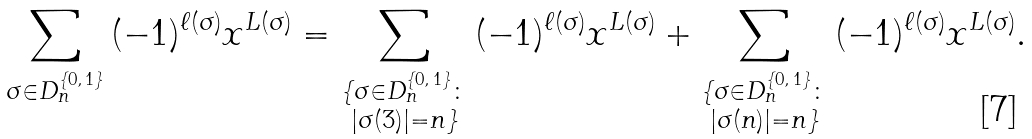<formula> <loc_0><loc_0><loc_500><loc_500>\sum _ { \sigma \in D _ { n } ^ { \{ 0 , \, 1 \} } } { ( - 1 ) ^ { \ell ( \sigma ) } x ^ { L ( \sigma ) } } & = \sum _ { \substack { \{ \sigma \in D _ { n } ^ { \{ 0 , \, 1 \} } \colon \\ | \sigma ( 3 ) | = n \} } } { ( - 1 ) ^ { \ell ( \sigma ) } x ^ { L ( \sigma ) } } + \sum _ { \substack { \{ \sigma \in D _ { n } ^ { \{ 0 , \, 1 \} } \colon \\ | \sigma ( n ) | = n \} } } { ( - 1 ) ^ { \ell ( \sigma ) } x ^ { L ( \sigma ) } } .</formula> 